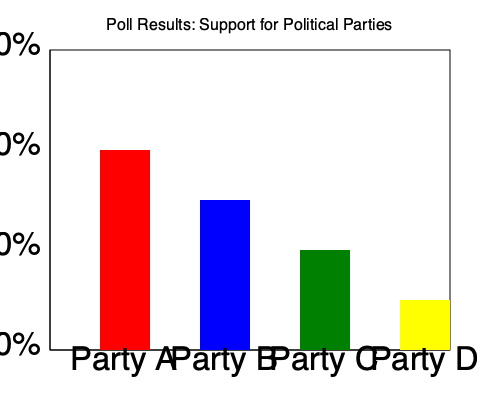As a student politician analyzing the poll results, what is the percentage point difference between the leading party and the party with the least support? To solve this question, we need to follow these steps:

1. Identify the leading party and the party with the least support:
   - Party A (red): 40% support
   - Party B (blue): 30% support
   - Party C (green): 20% support
   - Party D (yellow): 10% support

   Party A is leading with 40%, and Party D has the least support with 10%.

2. Calculate the difference between these two parties:
   $40\% - 10\% = 30\%$

3. Express the result in percentage points:
   The difference of 30% is equivalent to 30 percentage points.

As a student politician, understanding this gap is crucial for analyzing the political landscape and formulating strategies to address the differences in party support.
Answer: 30 percentage points 